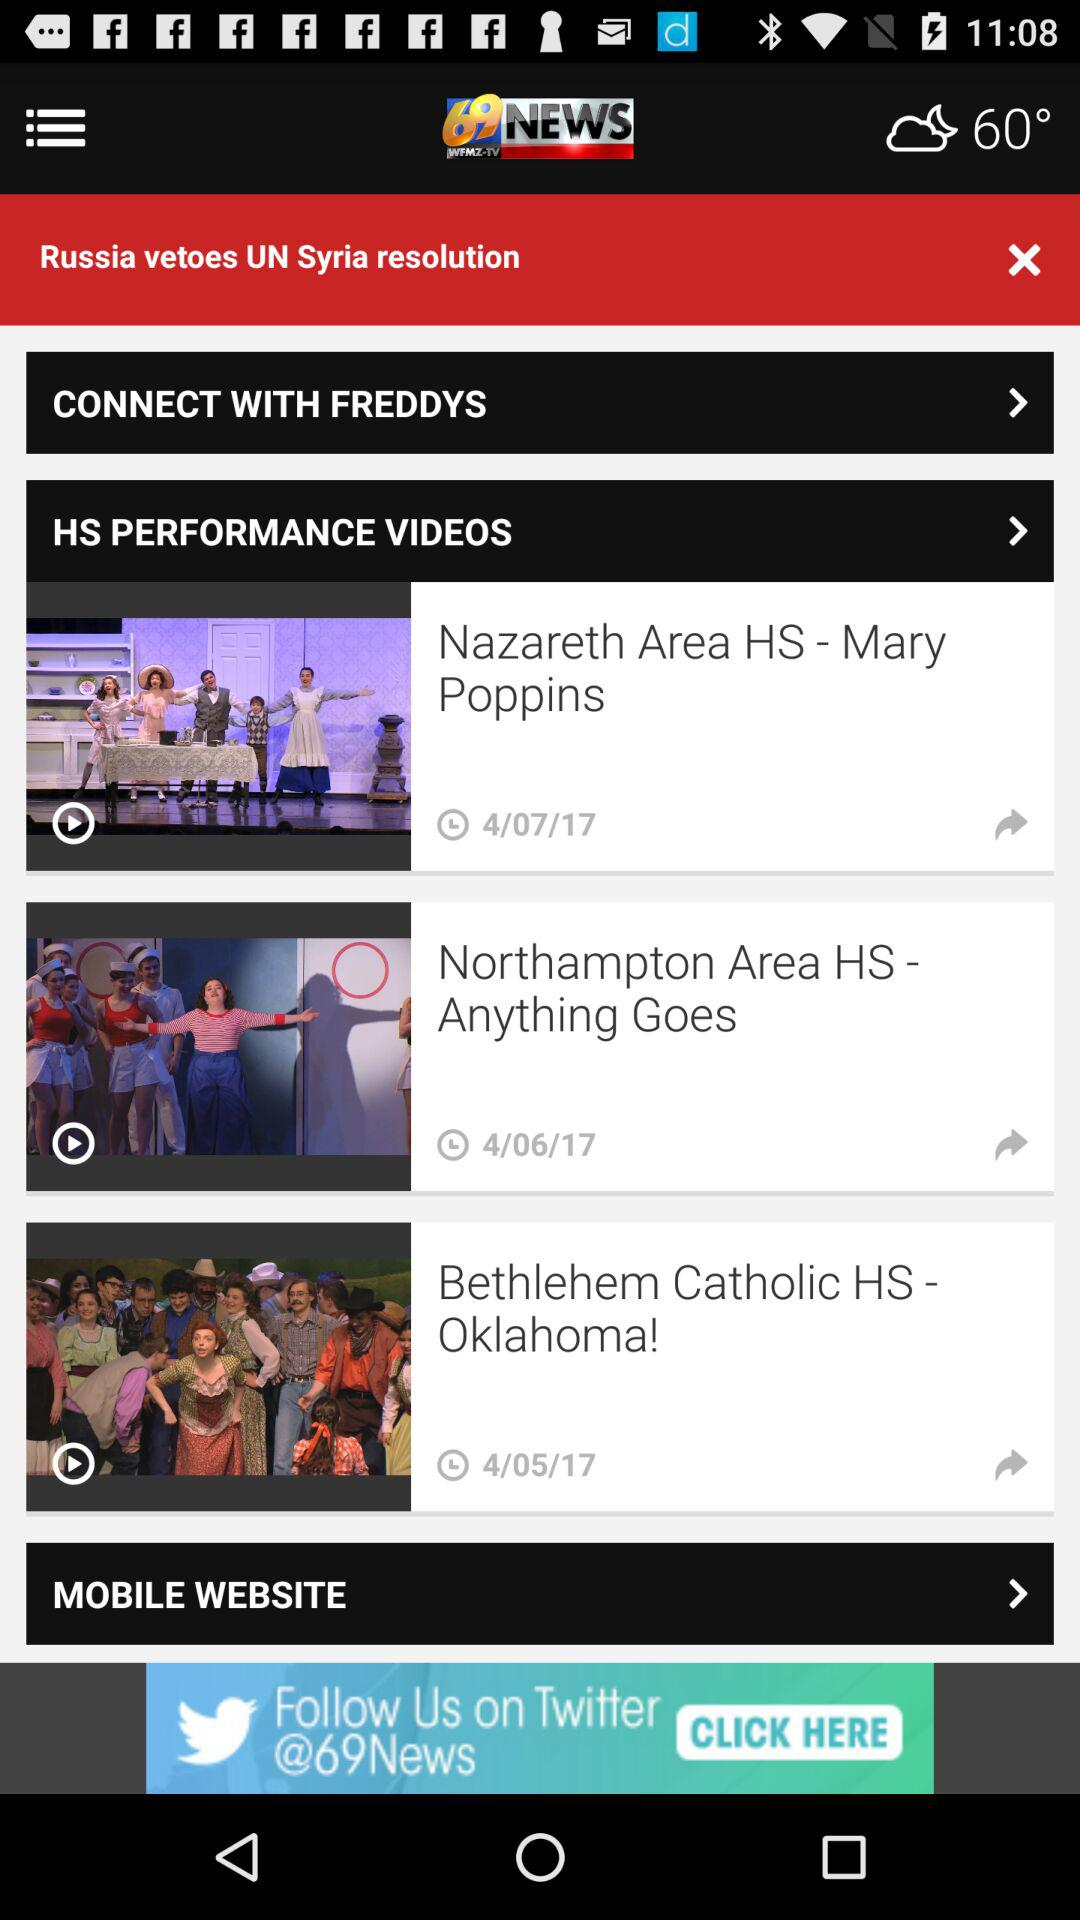How many HS Performance Videos are there?
Answer the question using a single word or phrase. 3 